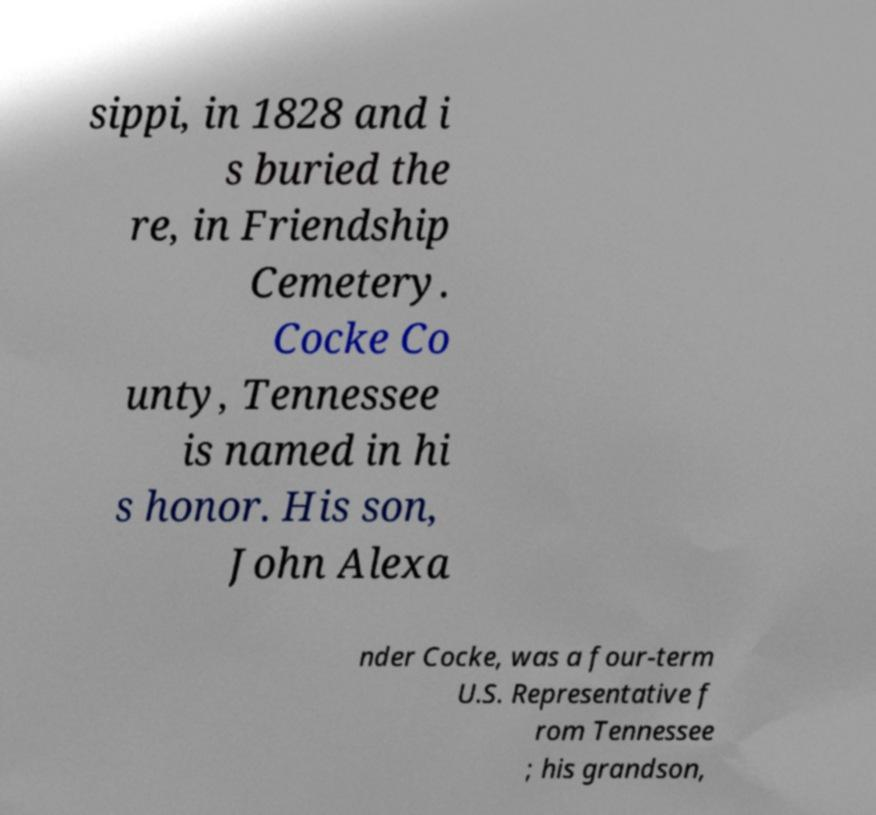I need the written content from this picture converted into text. Can you do that? sippi, in 1828 and i s buried the re, in Friendship Cemetery. Cocke Co unty, Tennessee is named in hi s honor. His son, John Alexa nder Cocke, was a four-term U.S. Representative f rom Tennessee ; his grandson, 